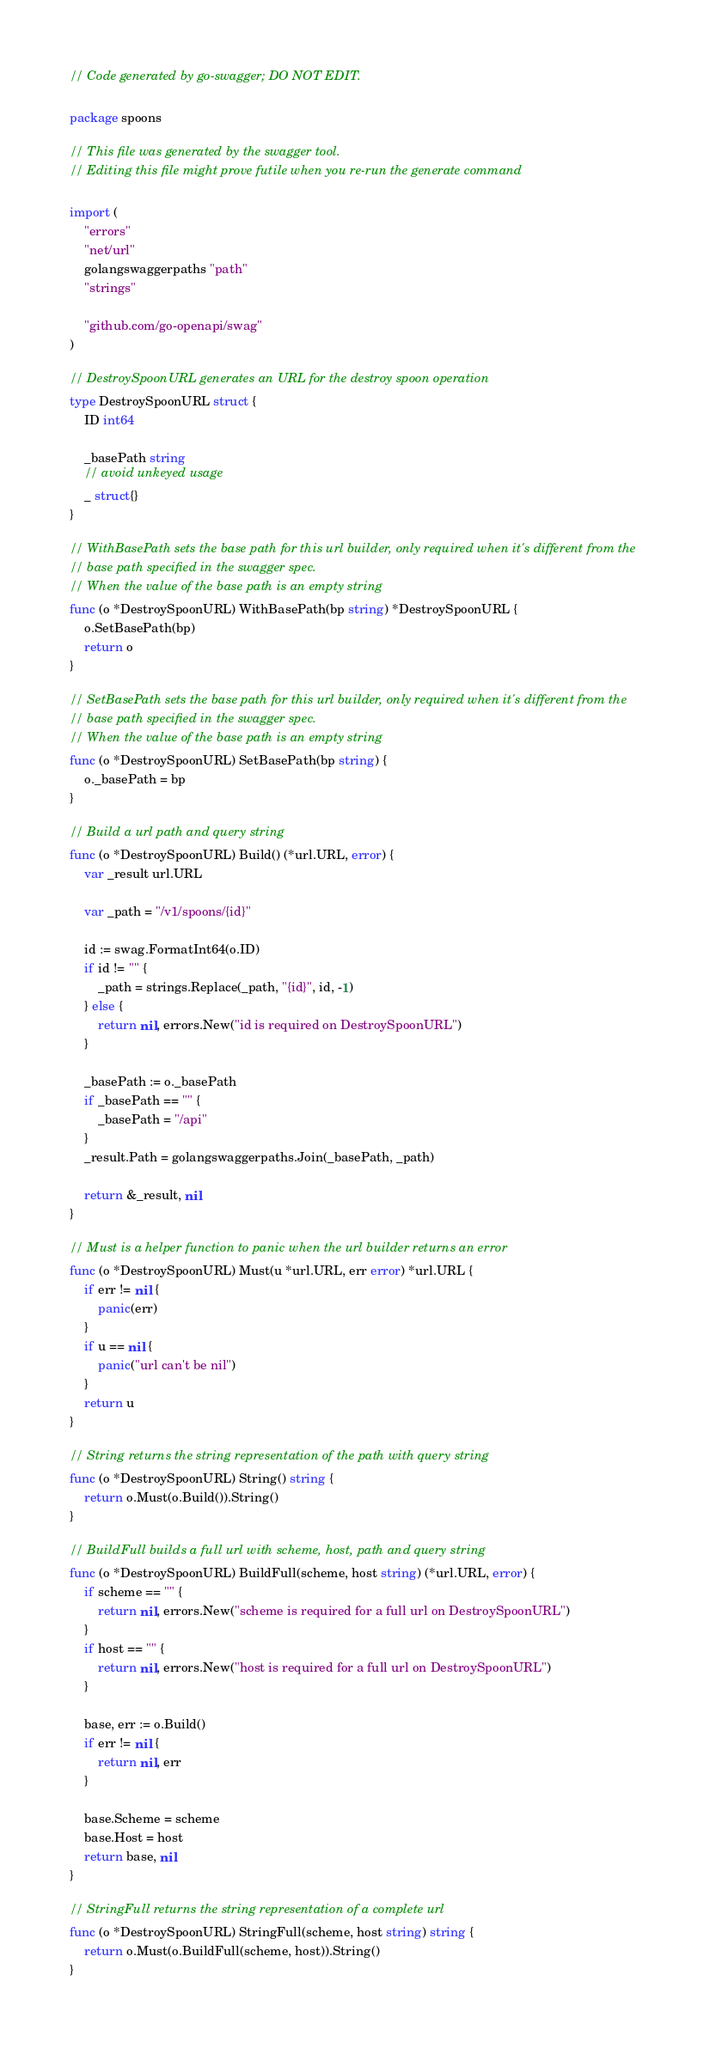<code> <loc_0><loc_0><loc_500><loc_500><_Go_>// Code generated by go-swagger; DO NOT EDIT.

package spoons

// This file was generated by the swagger tool.
// Editing this file might prove futile when you re-run the generate command

import (
	"errors"
	"net/url"
	golangswaggerpaths "path"
	"strings"

	"github.com/go-openapi/swag"
)

// DestroySpoonURL generates an URL for the destroy spoon operation
type DestroySpoonURL struct {
	ID int64

	_basePath string
	// avoid unkeyed usage
	_ struct{}
}

// WithBasePath sets the base path for this url builder, only required when it's different from the
// base path specified in the swagger spec.
// When the value of the base path is an empty string
func (o *DestroySpoonURL) WithBasePath(bp string) *DestroySpoonURL {
	o.SetBasePath(bp)
	return o
}

// SetBasePath sets the base path for this url builder, only required when it's different from the
// base path specified in the swagger spec.
// When the value of the base path is an empty string
func (o *DestroySpoonURL) SetBasePath(bp string) {
	o._basePath = bp
}

// Build a url path and query string
func (o *DestroySpoonURL) Build() (*url.URL, error) {
	var _result url.URL

	var _path = "/v1/spoons/{id}"

	id := swag.FormatInt64(o.ID)
	if id != "" {
		_path = strings.Replace(_path, "{id}", id, -1)
	} else {
		return nil, errors.New("id is required on DestroySpoonURL")
	}

	_basePath := o._basePath
	if _basePath == "" {
		_basePath = "/api"
	}
	_result.Path = golangswaggerpaths.Join(_basePath, _path)

	return &_result, nil
}

// Must is a helper function to panic when the url builder returns an error
func (o *DestroySpoonURL) Must(u *url.URL, err error) *url.URL {
	if err != nil {
		panic(err)
	}
	if u == nil {
		panic("url can't be nil")
	}
	return u
}

// String returns the string representation of the path with query string
func (o *DestroySpoonURL) String() string {
	return o.Must(o.Build()).String()
}

// BuildFull builds a full url with scheme, host, path and query string
func (o *DestroySpoonURL) BuildFull(scheme, host string) (*url.URL, error) {
	if scheme == "" {
		return nil, errors.New("scheme is required for a full url on DestroySpoonURL")
	}
	if host == "" {
		return nil, errors.New("host is required for a full url on DestroySpoonURL")
	}

	base, err := o.Build()
	if err != nil {
		return nil, err
	}

	base.Scheme = scheme
	base.Host = host
	return base, nil
}

// StringFull returns the string representation of a complete url
func (o *DestroySpoonURL) StringFull(scheme, host string) string {
	return o.Must(o.BuildFull(scheme, host)).String()
}
</code> 